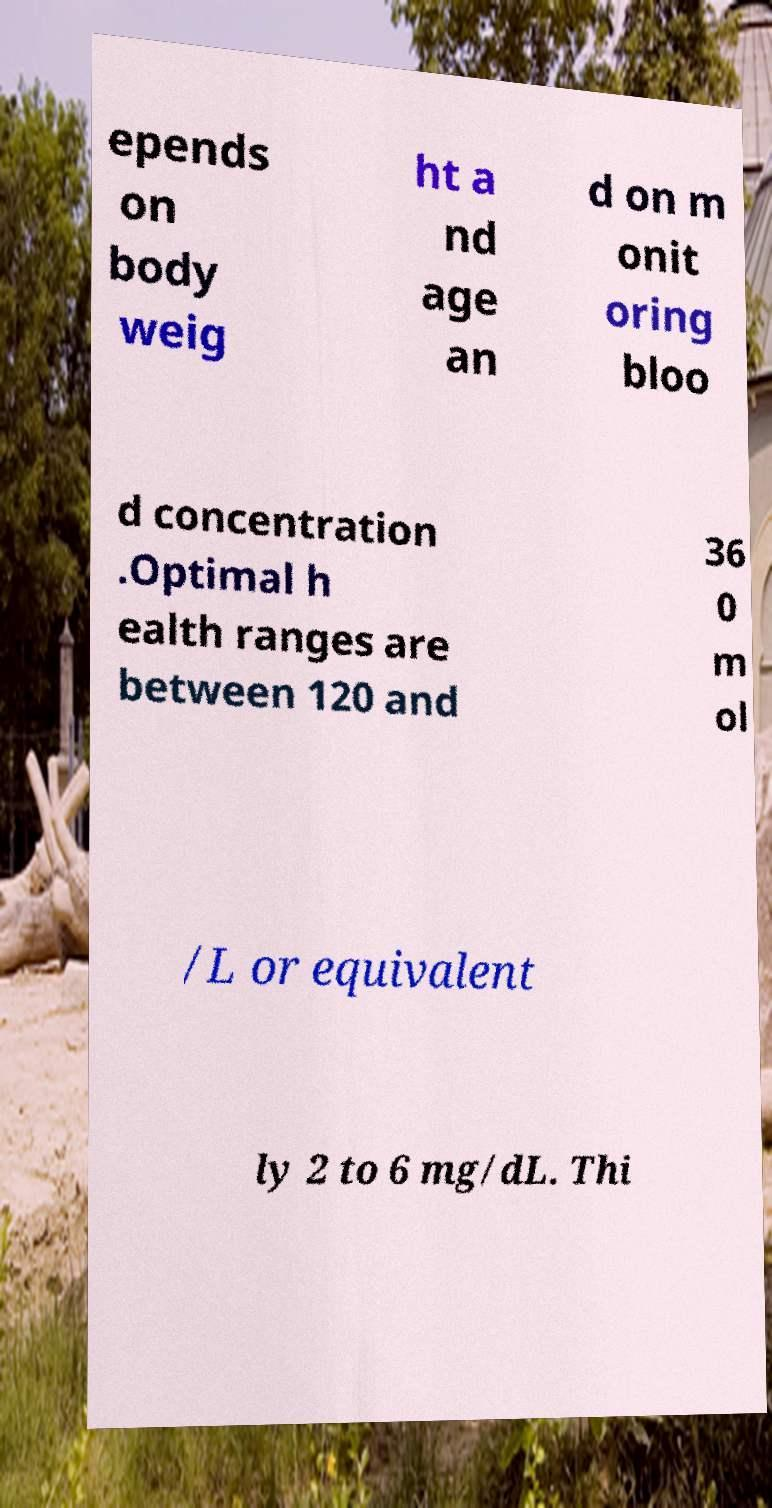What messages or text are displayed in this image? I need them in a readable, typed format. epends on body weig ht a nd age an d on m onit oring bloo d concentration .Optimal h ealth ranges are between 120 and 36 0 m ol /L or equivalent ly 2 to 6 mg/dL. Thi 